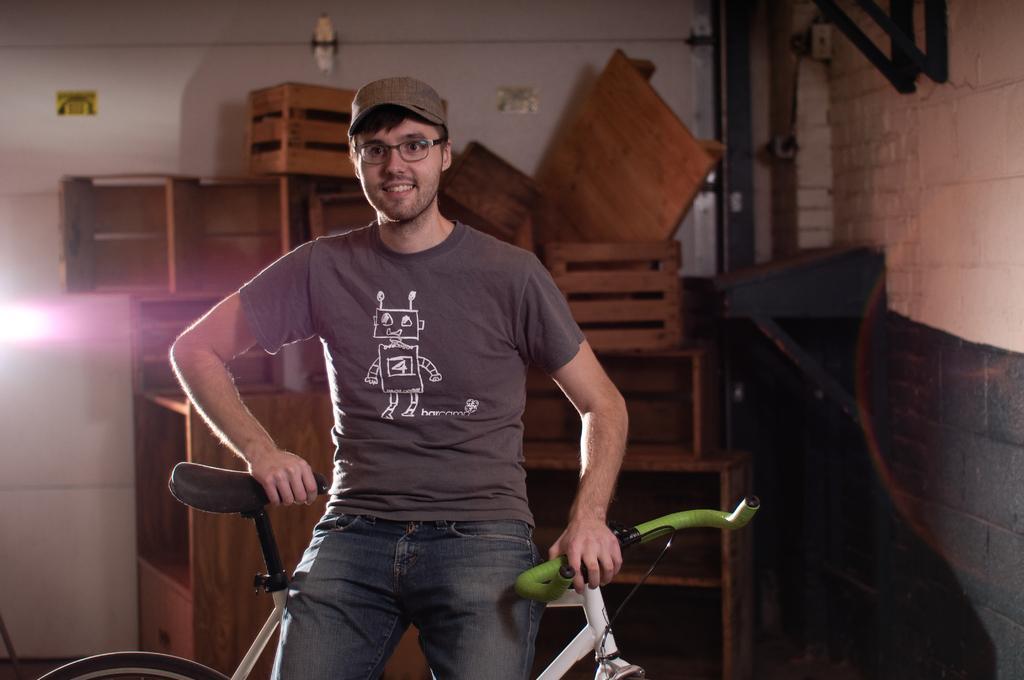Could you give a brief overview of what you see in this image? In this image, we can see a person wearing clothes and sitting on the cycle. There are some boxes in front of the wall. There are pipes in the top right of the image. 